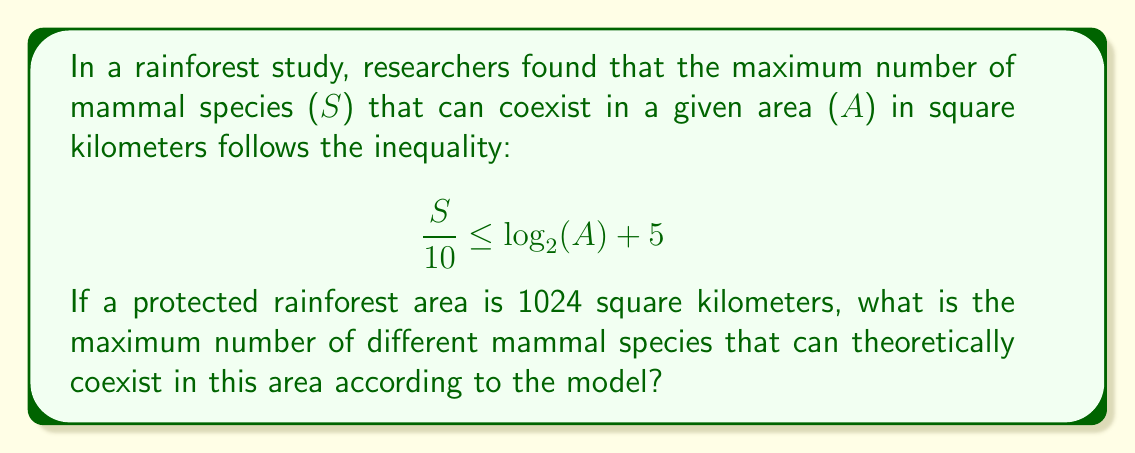Provide a solution to this math problem. To solve this problem, we need to follow these steps:

1) We are given that $A = 1024$ square kilometers.

2) We need to substitute this value into the inequality:

   $$ \frac{S}{10} \leq \log_2(1024) + 5 $$

3) Let's simplify the right side of the inequality:
   
   $\log_2(1024) = 10$ (since $2^{10} = 1024$)

   So our inequality becomes:

   $$ \frac{S}{10} \leq 10 + 5 = 15 $$

4) To find the maximum value of $S$, we consider the equality:

   $$ \frac{S}{10} = 15 $$

5) Multiply both sides by 10:

   $$ S = 15 \times 10 = 150 $$

6) Since $S$ represents the number of species, it must be a whole number. The inequality allows for any value of $S$ up to and including 150.

Therefore, the maximum number of different mammal species that can theoretically coexist in this area is 150.
Answer: 150 species 